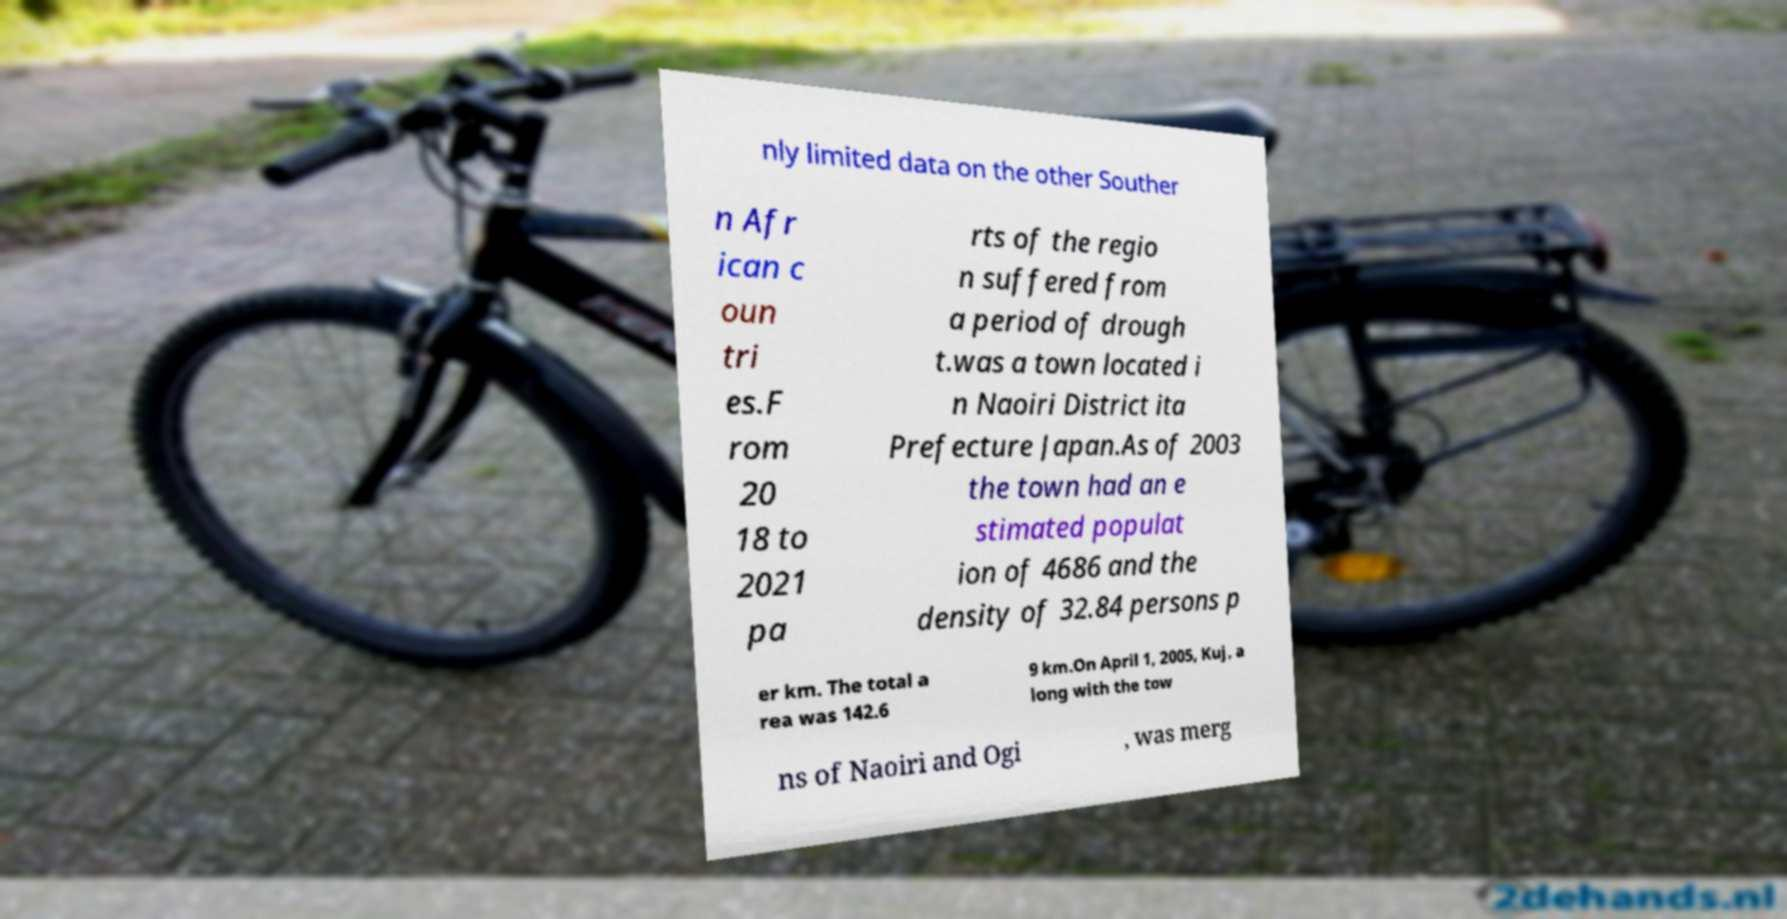Could you extract and type out the text from this image? nly limited data on the other Souther n Afr ican c oun tri es.F rom 20 18 to 2021 pa rts of the regio n suffered from a period of drough t.was a town located i n Naoiri District ita Prefecture Japan.As of 2003 the town had an e stimated populat ion of 4686 and the density of 32.84 persons p er km. The total a rea was 142.6 9 km.On April 1, 2005, Kuj, a long with the tow ns of Naoiri and Ogi , was merg 